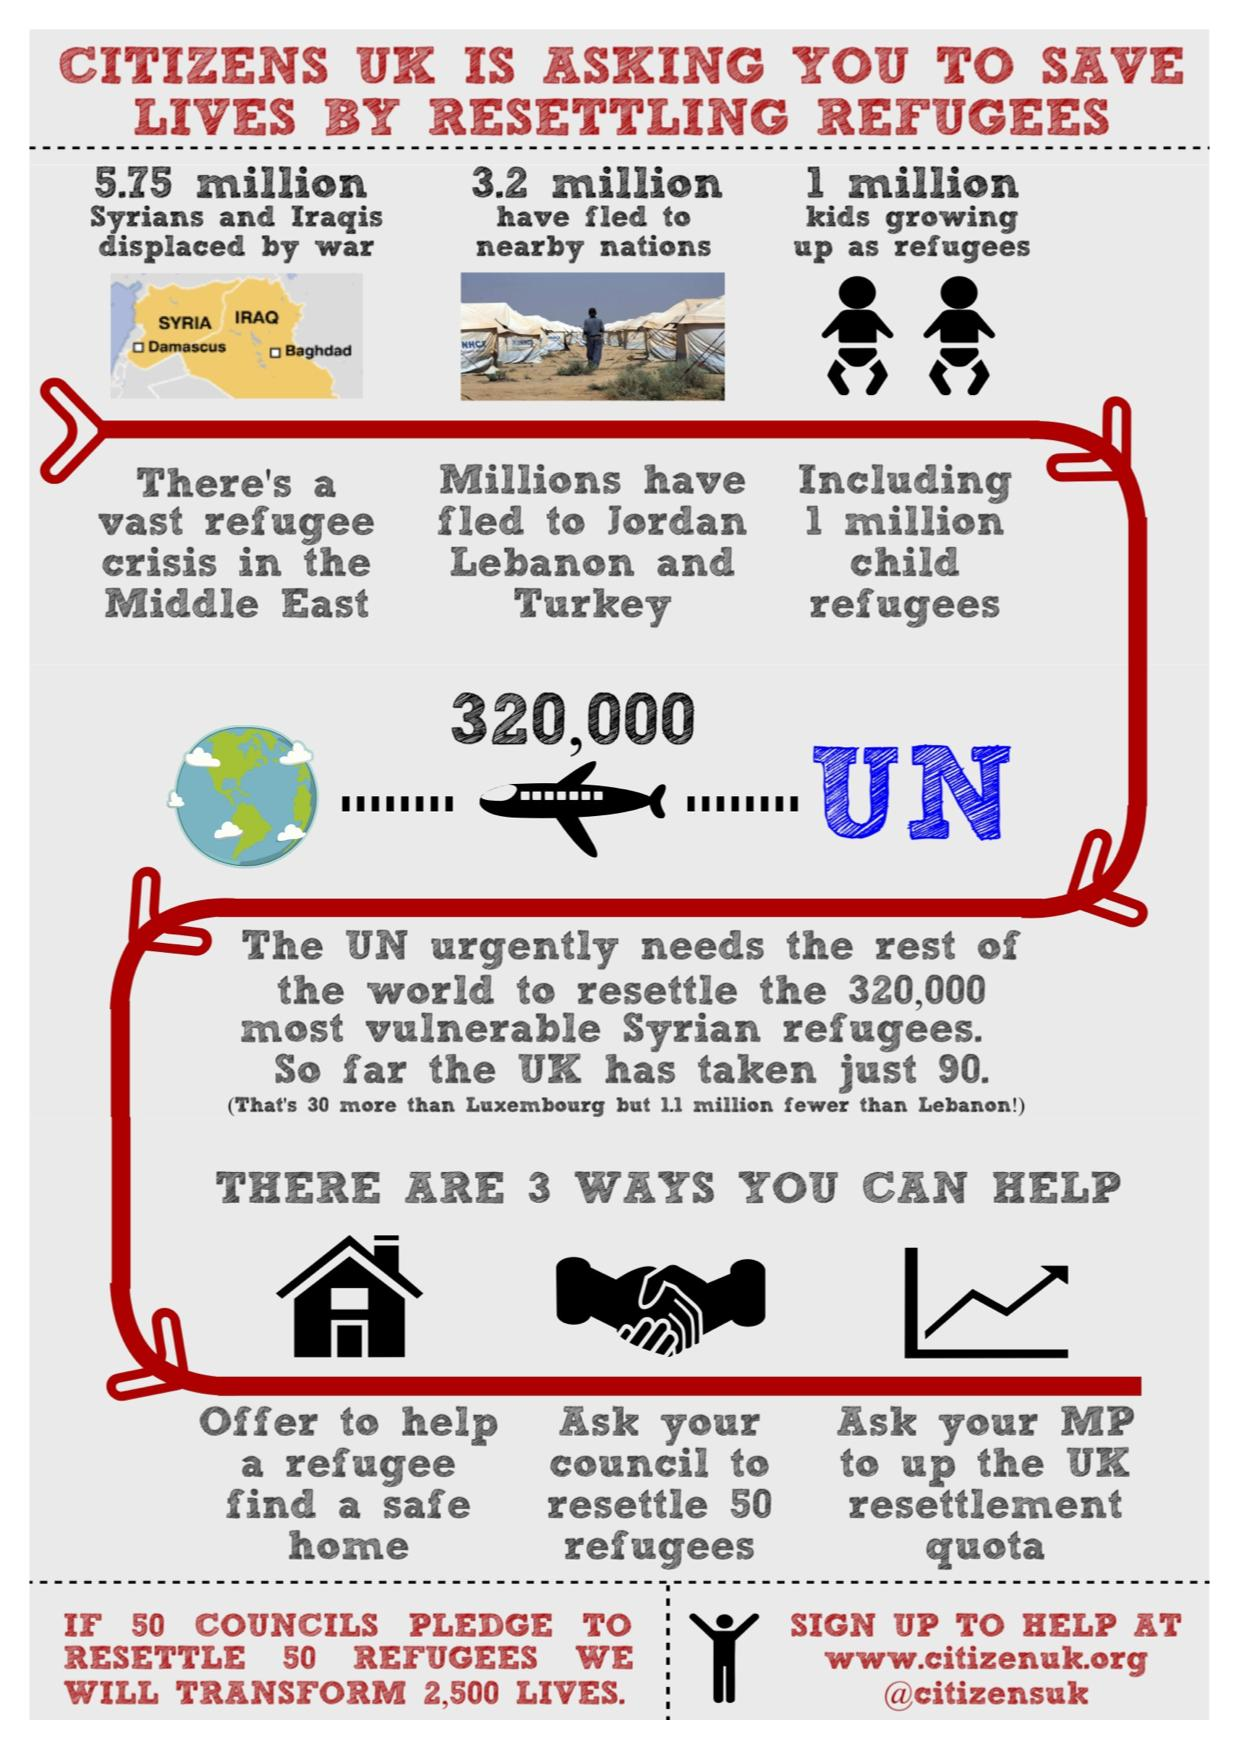Outline some significant characteristics in this image. There are approximately 5.75 million refugees in the Middle East. The child refugee population is estimated to be one million. The refugee population who have fled to Jordan, Lebanon, and Turkey is 3.2 million. In 2022, the UK council only took in 90 vulnerable Syrian refugees, despite its promise to provide safe haven to a larger number of displaced individuals. 